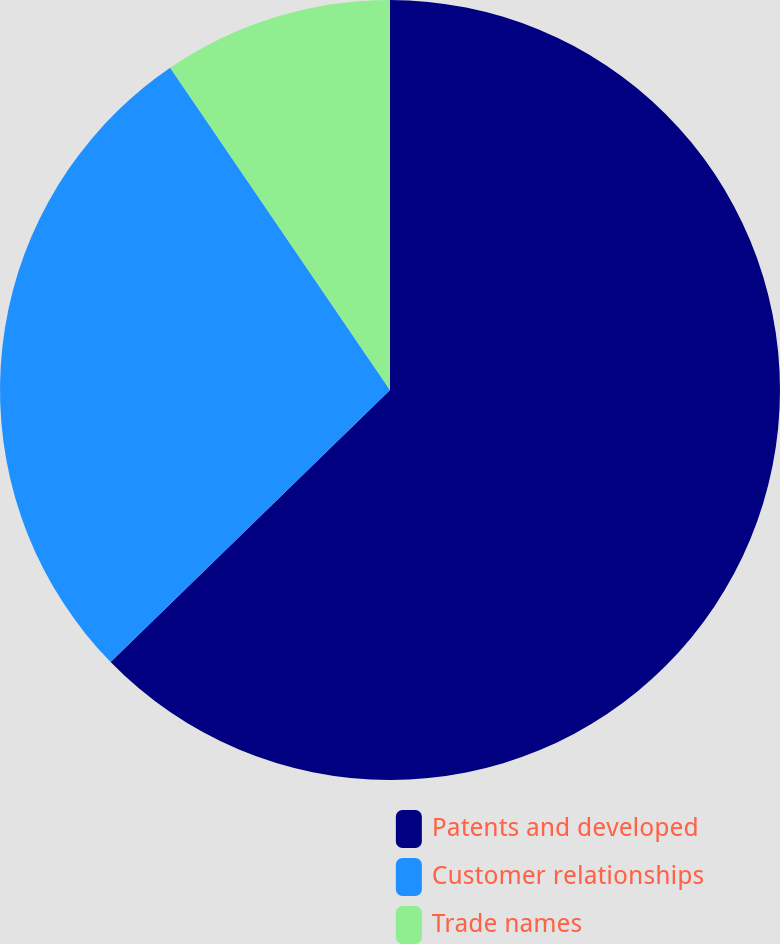<chart> <loc_0><loc_0><loc_500><loc_500><pie_chart><fcel>Patents and developed<fcel>Customer relationships<fcel>Trade names<nl><fcel>62.71%<fcel>27.76%<fcel>9.53%<nl></chart> 